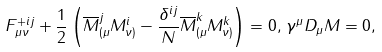Convert formula to latex. <formula><loc_0><loc_0><loc_500><loc_500>F ^ { + i j } _ { \mu \nu } + \frac { 1 } { 2 } \left ( \overline { M } ^ { j } _ { ( \mu } M ^ { i } _ { \nu ) } - \frac { \delta ^ { i j } } { N } \overline { M } ^ { k } _ { ( \mu } M ^ { k } _ { \nu ) } \right ) = 0 , \, \gamma ^ { \mu } D _ { \mu } M = 0 ,</formula> 